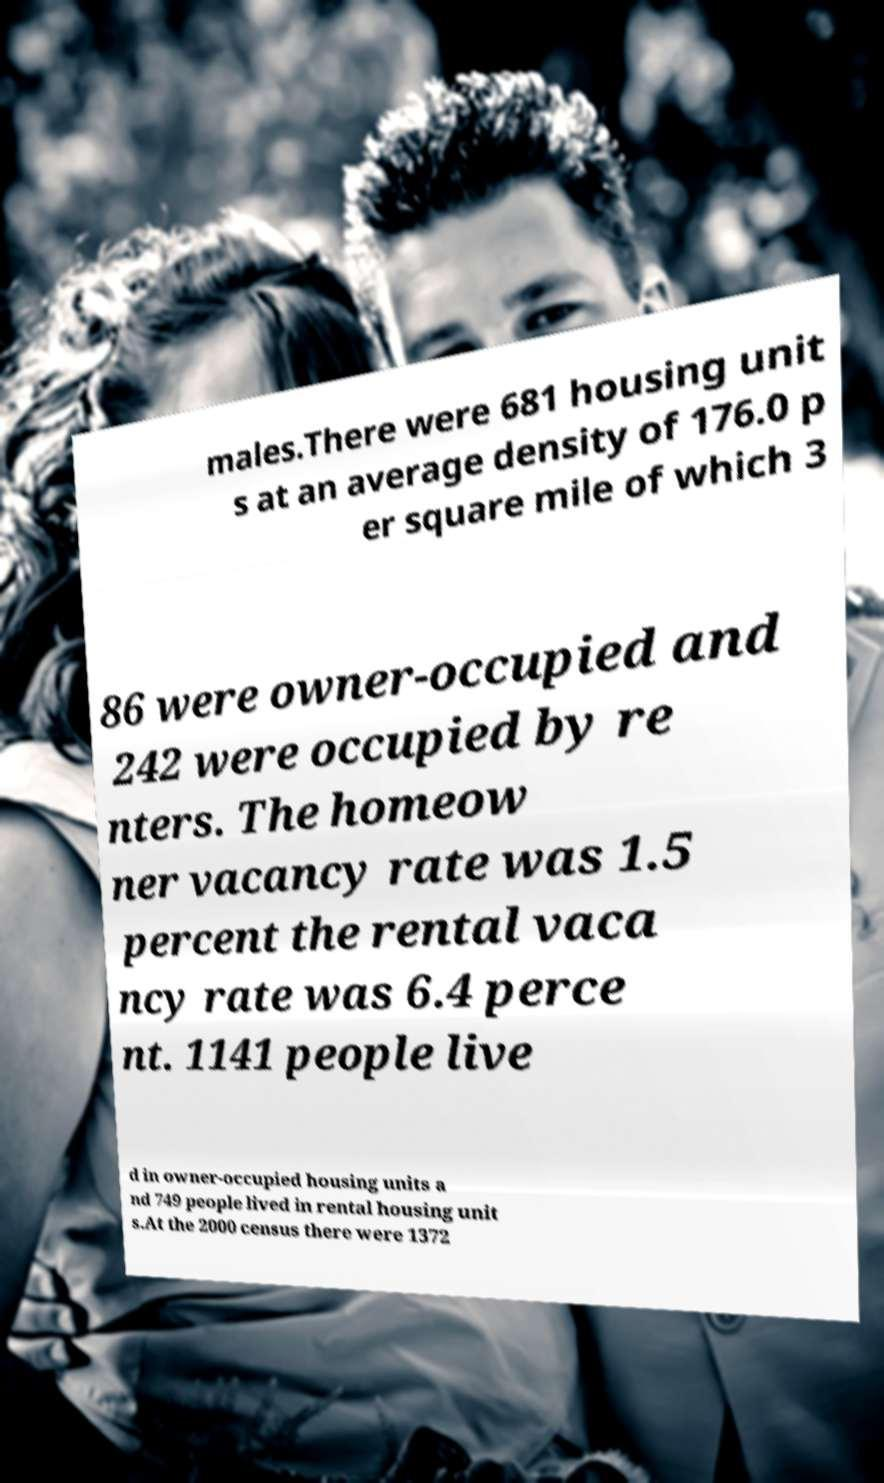Can you accurately transcribe the text from the provided image for me? males.There were 681 housing unit s at an average density of 176.0 p er square mile of which 3 86 were owner-occupied and 242 were occupied by re nters. The homeow ner vacancy rate was 1.5 percent the rental vaca ncy rate was 6.4 perce nt. 1141 people live d in owner-occupied housing units a nd 749 people lived in rental housing unit s.At the 2000 census there were 1372 